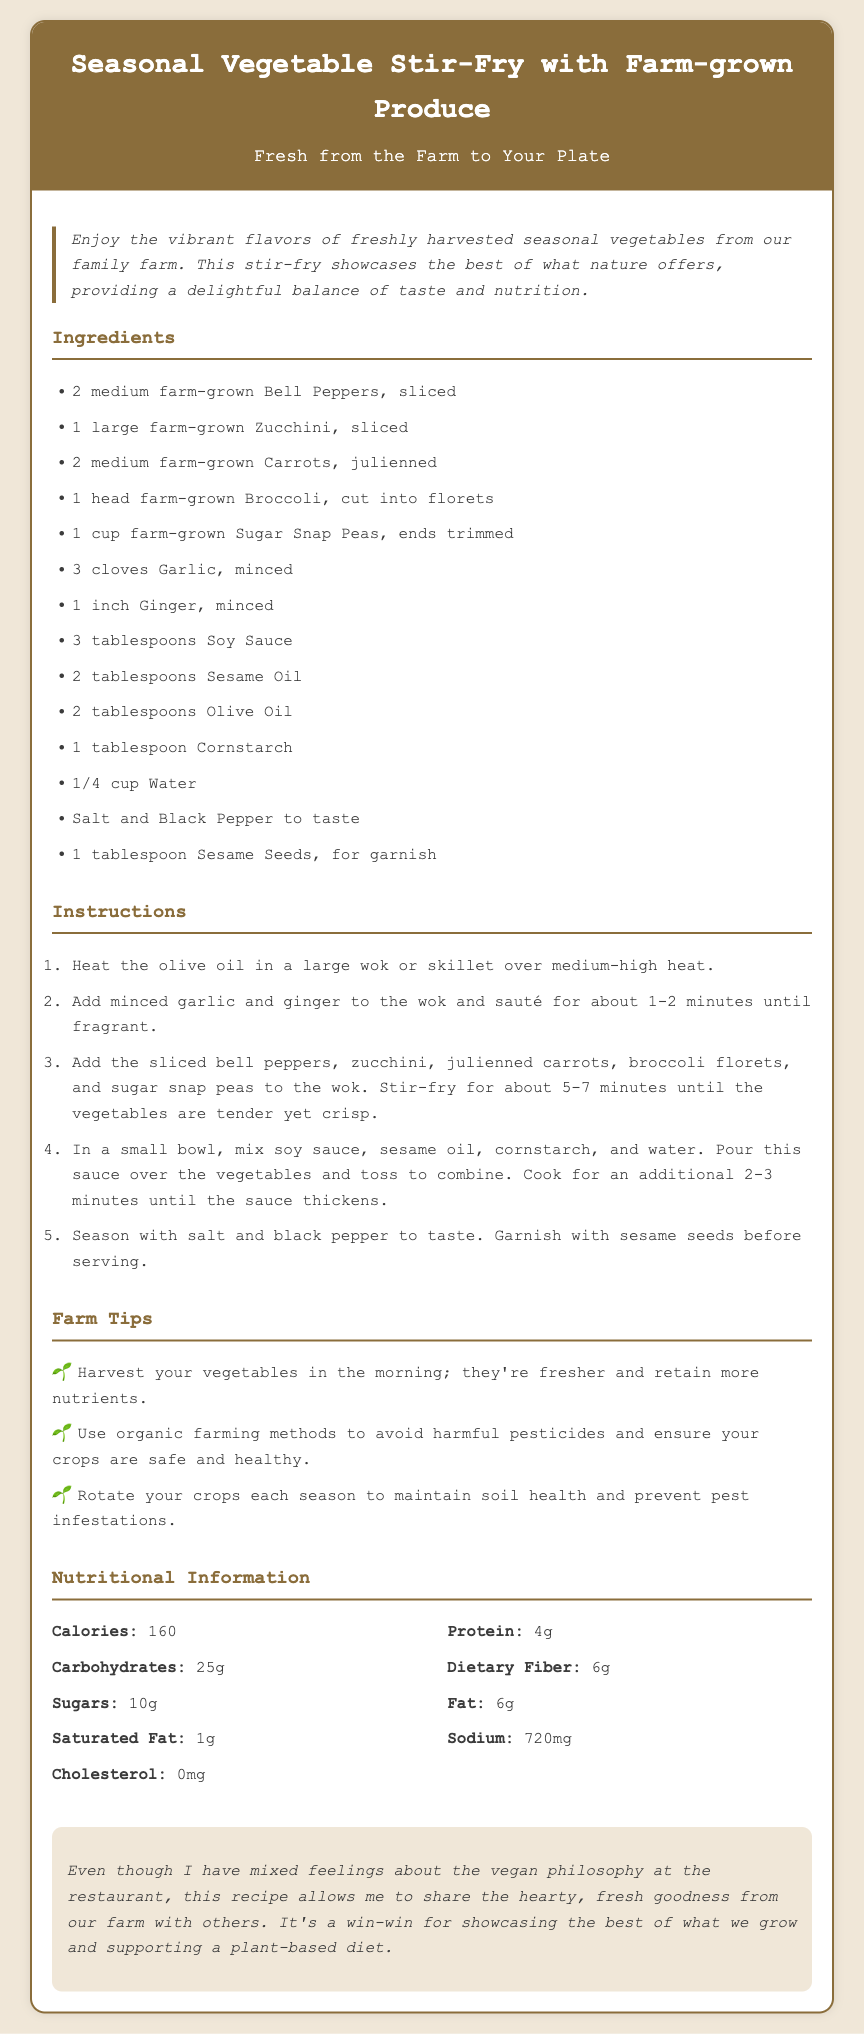what are the main ingredients? The main ingredients are listed in the ingredients section of the document. They include various fresh vegetables and seasonings.
Answer: Bell Peppers, Zucchini, Carrots, Broccoli, Sugar Snap Peas, Garlic, Ginger, Soy Sauce, Sesame Oil, Olive Oil, Cornstarch, Water, Salt, Black Pepper, Sesame Seeds how long should the vegetables be stir-fried? The instructions specify that the vegetables should be stir-fried for about 5-7 minutes.
Answer: 5-7 minutes what type of oil is used in the recipe? The ingredients list includes both sesame oil and olive oil.
Answer: Sesame Oil, Olive Oil how many cloves of garlic are required? This is stated in the ingredients section where it specifically mentions the amount required.
Answer: 3 cloves what is the calorie count for this dish? The nutritional information indicates the total calories for the dish.
Answer: 160 how does the document describe the origin of the vegetables? The introduction highlights the fresh vegetables as being harvested from the family farm, showcasing the connection to local produce.
Answer: Freshly harvested seasonal vegetables from our family farm what is recommended for pest infestations? The farm tips section suggests crop rotation to maintain soil health and prevent pest infestations.
Answer: Rotate your crops what is mentioned about sodium content? The nutritional information section states the sodium amount, which is a key aspect of the dish's health profile.
Answer: 720mg what is the purpose of the personal notes section? The personal notes provide insights into the author's perspective and feelings about sharing farm produce while acknowledging a vegan philosophy.
Answer: Share the hearty, fresh goodness from our farm with others 